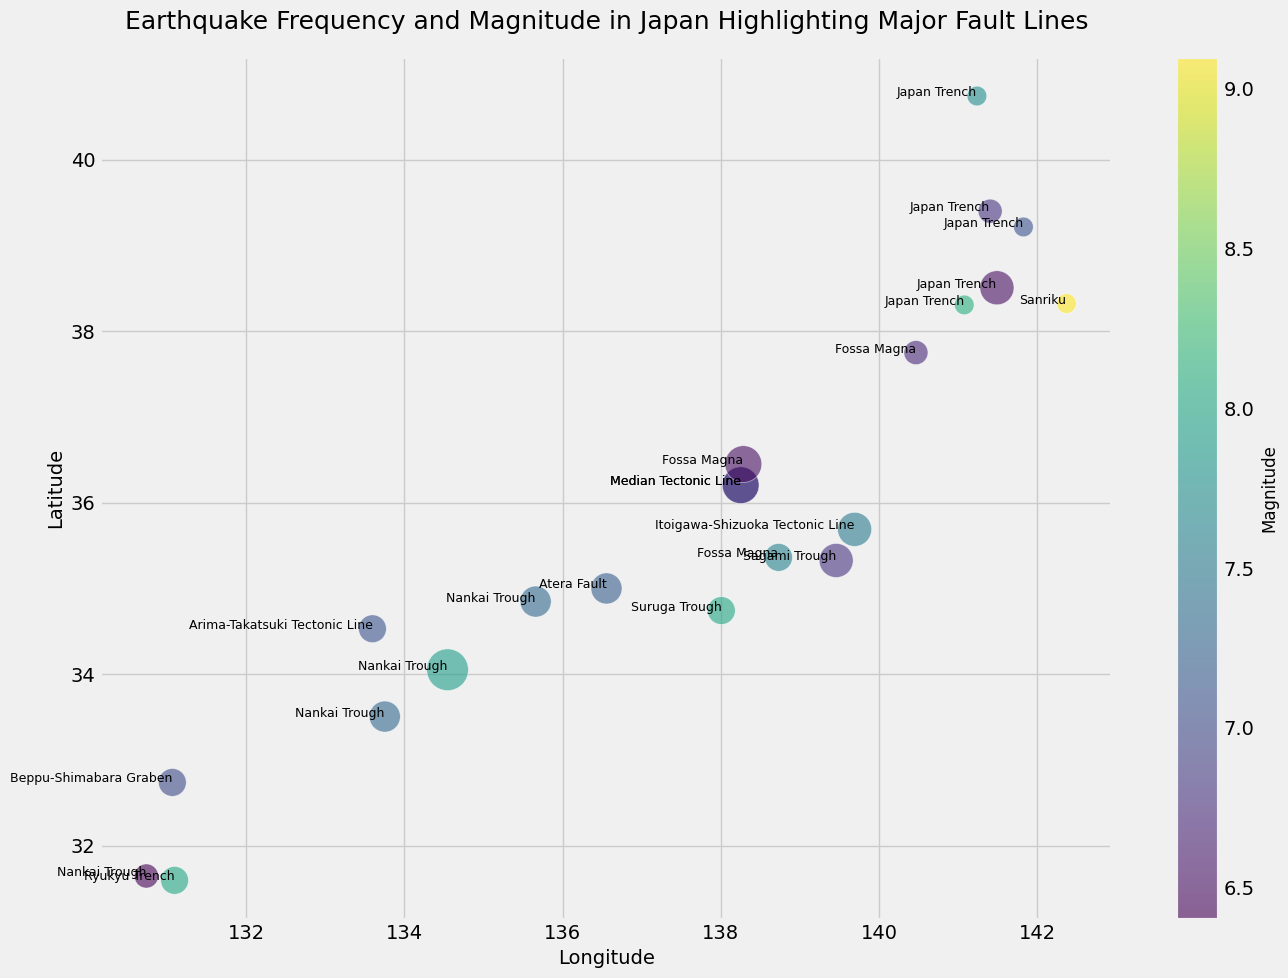Which fault line has the largest earthquake frequency according to the bubble sizes? The size of the bubbles represents earthquake frequency. The "Median Tectonic Line" has the largest bubbles, indicating the highest frequency.
Answer: Median Tectonic Line Which earthquake has the highest magnitude? The color bar represents magnitude, where a darker color indicates a higher magnitude. The earthquake near (142.369, 38.322) has the darkest color, corresponding to a magnitude of 9.1.
Answer: Sanriku Which fault line shows the most diversity in earthquake magnitudes based on the colors of the bubbles? The "Japan Trench" has bubbles with varying colors ranging from lighter to darker shades, indicating a diverse range of magnitudes from 6.5 to 8.1.
Answer: Japan Trench How does the frequency of earthquakes along the "Nankai Trough" compare to the "Itoigawa-Shizuoka Tectonic Line"? The sizes of the bubbles representing the "Nankai Trough" are larger than those representing the "Itoigawa-Shizuoka Tectonic Line", indicating a higher frequency along the "Nankai Trough".
Answer: Nankai Trough What is the average magnitude of earthquakes along the "Fossa Magna"? The earthquakes along the "Fossa Magna" have magnitudes of 6.7, 7.6, and 6.5. The average magnitude is calculated as (6.7 + 7.6 + 6.5) / 3 = 6.93.
Answer: 6.93 Which fault line has earthquakes occurring at the deepest depths and what are those depths? "Japan Trench" has earthquakes at depths of 30, 35, and 33, which are the deepest among all fault lines.
Answer: 30, 35, 33 Among the plotted fault lines, which one has the highest average frequency of earthquakes per region? The "Median Tectonic Line" has frequencies of 7 and 7. Calculating the average frequency results in (7 + 7) / 2 = 7.
Answer: Median Tectonic Line Compare the magnitude of earthquakes along the "Nankai Trough" and "Ryukyu Trench". Which one has a higher average magnitude? The "Nankai Trough" has magnitudes of 7.3, 7.9, 8.0, 7.3, and 6.4, while the "Ryukyu Trench" has a magnitude of 8.0. The average for "Nankai Trough" is (7.3 + 7.9 + 8.0 + 7.3 + 6.4) / 5 = 7.38. "Ryukyu Trench" magnitude is 8.0, which is higher.
Answer: Ryukyu Trench 